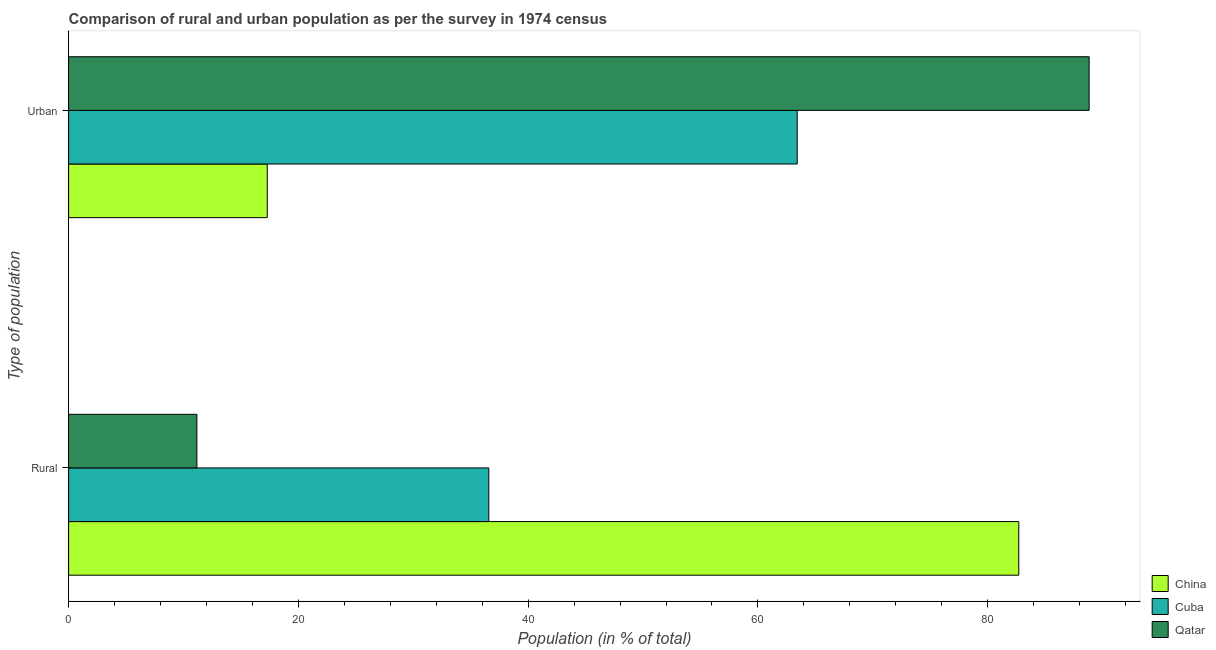How many different coloured bars are there?
Offer a terse response. 3. How many groups of bars are there?
Provide a succinct answer. 2. Are the number of bars per tick equal to the number of legend labels?
Provide a succinct answer. Yes. How many bars are there on the 2nd tick from the top?
Provide a short and direct response. 3. How many bars are there on the 2nd tick from the bottom?
Provide a short and direct response. 3. What is the label of the 2nd group of bars from the top?
Provide a short and direct response. Rural. What is the rural population in Cuba?
Make the answer very short. 36.58. Across all countries, what is the maximum urban population?
Keep it short and to the point. 88.83. Across all countries, what is the minimum urban population?
Your answer should be compact. 17.29. In which country was the rural population maximum?
Offer a very short reply. China. In which country was the rural population minimum?
Ensure brevity in your answer.  Qatar. What is the total urban population in the graph?
Your response must be concise. 169.55. What is the difference between the urban population in China and that in Cuba?
Keep it short and to the point. -46.13. What is the difference between the urban population in Cuba and the rural population in China?
Provide a short and direct response. -19.28. What is the average urban population per country?
Make the answer very short. 56.52. What is the difference between the rural population and urban population in Cuba?
Make the answer very short. -26.85. In how many countries, is the urban population greater than 28 %?
Offer a terse response. 2. What is the ratio of the rural population in Qatar to that in China?
Give a very brief answer. 0.14. What does the 3rd bar from the bottom in Urban represents?
Offer a very short reply. Qatar. What is the difference between two consecutive major ticks on the X-axis?
Keep it short and to the point. 20. Are the values on the major ticks of X-axis written in scientific E-notation?
Provide a succinct answer. No. How many legend labels are there?
Make the answer very short. 3. What is the title of the graph?
Provide a short and direct response. Comparison of rural and urban population as per the survey in 1974 census. Does "Middle East & North Africa (developing only)" appear as one of the legend labels in the graph?
Keep it short and to the point. No. What is the label or title of the X-axis?
Your response must be concise. Population (in % of total). What is the label or title of the Y-axis?
Provide a short and direct response. Type of population. What is the Population (in % of total) in China in Rural?
Offer a terse response. 82.71. What is the Population (in % of total) of Cuba in Rural?
Make the answer very short. 36.58. What is the Population (in % of total) in Qatar in Rural?
Your answer should be very brief. 11.17. What is the Population (in % of total) of China in Urban?
Keep it short and to the point. 17.29. What is the Population (in % of total) of Cuba in Urban?
Offer a terse response. 63.42. What is the Population (in % of total) of Qatar in Urban?
Provide a succinct answer. 88.83. Across all Type of population, what is the maximum Population (in % of total) in China?
Your response must be concise. 82.71. Across all Type of population, what is the maximum Population (in % of total) of Cuba?
Make the answer very short. 63.42. Across all Type of population, what is the maximum Population (in % of total) in Qatar?
Your answer should be compact. 88.83. Across all Type of population, what is the minimum Population (in % of total) of China?
Offer a terse response. 17.29. Across all Type of population, what is the minimum Population (in % of total) in Cuba?
Your answer should be very brief. 36.58. Across all Type of population, what is the minimum Population (in % of total) in Qatar?
Ensure brevity in your answer.  11.17. What is the total Population (in % of total) in China in the graph?
Make the answer very short. 100. What is the total Population (in % of total) of Qatar in the graph?
Provide a succinct answer. 100. What is the difference between the Population (in % of total) in China in Rural and that in Urban?
Offer a terse response. 65.42. What is the difference between the Population (in % of total) of Cuba in Rural and that in Urban?
Keep it short and to the point. -26.85. What is the difference between the Population (in % of total) of Qatar in Rural and that in Urban?
Provide a short and direct response. -77.66. What is the difference between the Population (in % of total) of China in Rural and the Population (in % of total) of Cuba in Urban?
Your response must be concise. 19.29. What is the difference between the Population (in % of total) of China in Rural and the Population (in % of total) of Qatar in Urban?
Ensure brevity in your answer.  -6.12. What is the difference between the Population (in % of total) of Cuba in Rural and the Population (in % of total) of Qatar in Urban?
Your response must be concise. -52.26. What is the average Population (in % of total) in China per Type of population?
Offer a very short reply. 50. What is the average Population (in % of total) of Qatar per Type of population?
Provide a short and direct response. 50. What is the difference between the Population (in % of total) of China and Population (in % of total) of Cuba in Rural?
Keep it short and to the point. 46.13. What is the difference between the Population (in % of total) of China and Population (in % of total) of Qatar in Rural?
Provide a short and direct response. 71.54. What is the difference between the Population (in % of total) of Cuba and Population (in % of total) of Qatar in Rural?
Make the answer very short. 25.41. What is the difference between the Population (in % of total) of China and Population (in % of total) of Cuba in Urban?
Ensure brevity in your answer.  -46.13. What is the difference between the Population (in % of total) in China and Population (in % of total) in Qatar in Urban?
Give a very brief answer. -71.54. What is the difference between the Population (in % of total) of Cuba and Population (in % of total) of Qatar in Urban?
Your response must be concise. -25.41. What is the ratio of the Population (in % of total) in China in Rural to that in Urban?
Your response must be concise. 4.78. What is the ratio of the Population (in % of total) of Cuba in Rural to that in Urban?
Your answer should be compact. 0.58. What is the ratio of the Population (in % of total) of Qatar in Rural to that in Urban?
Keep it short and to the point. 0.13. What is the difference between the highest and the second highest Population (in % of total) in China?
Offer a very short reply. 65.42. What is the difference between the highest and the second highest Population (in % of total) of Cuba?
Keep it short and to the point. 26.85. What is the difference between the highest and the second highest Population (in % of total) of Qatar?
Ensure brevity in your answer.  77.66. What is the difference between the highest and the lowest Population (in % of total) of China?
Your answer should be very brief. 65.42. What is the difference between the highest and the lowest Population (in % of total) in Cuba?
Offer a terse response. 26.85. What is the difference between the highest and the lowest Population (in % of total) of Qatar?
Provide a short and direct response. 77.66. 